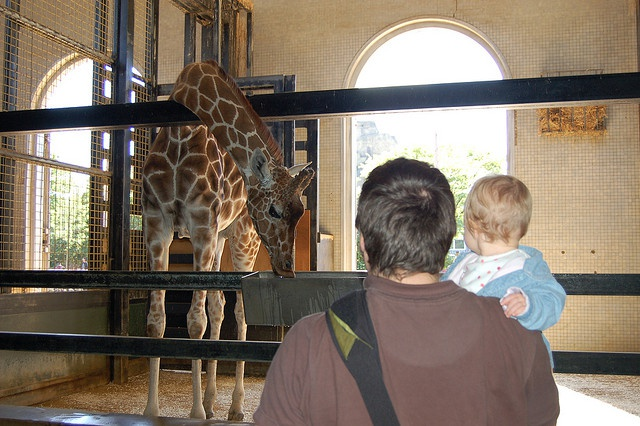Describe the objects in this image and their specific colors. I can see people in gray and black tones, giraffe in gray, maroon, and black tones, people in gray, lightgray, lightblue, tan, and darkgray tones, handbag in gray and black tones, and backpack in gray and black tones in this image. 